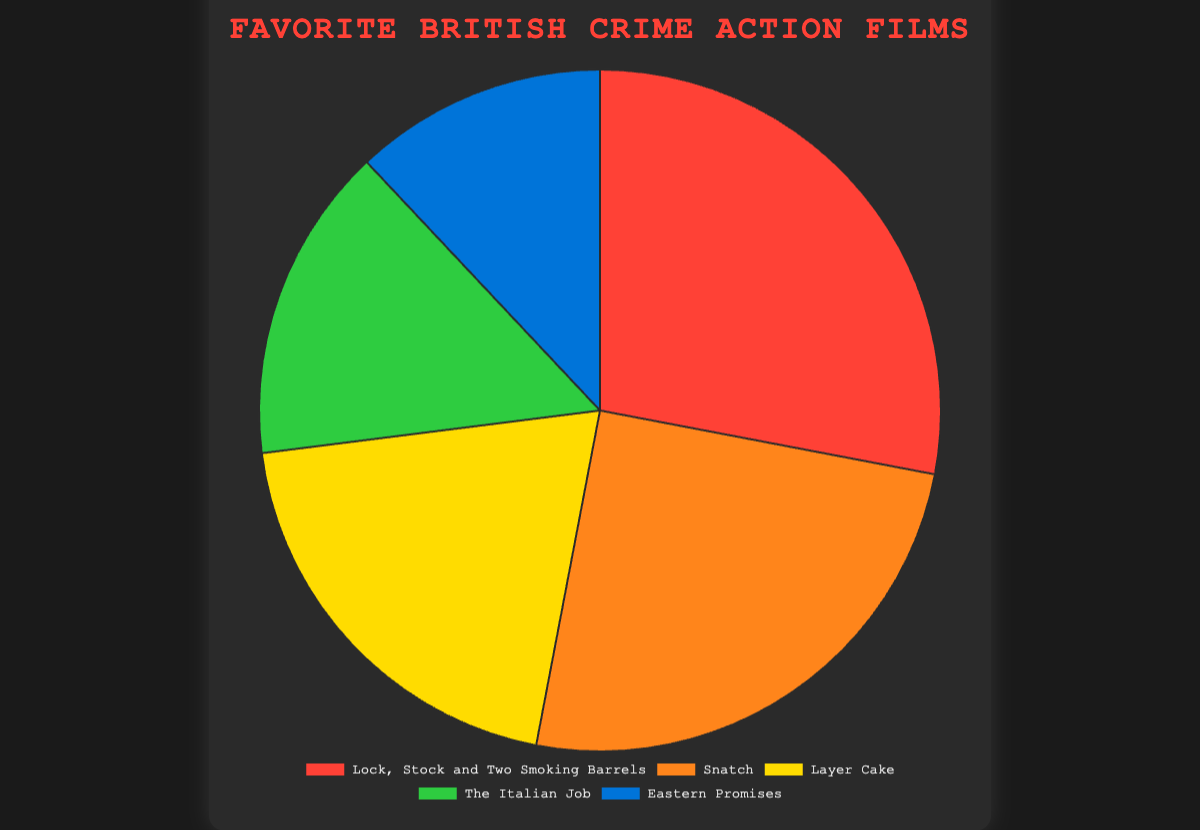Which film has the highest viewership percentage? The chart shows five films with their corresponding viewership percentages. The film "Lock, Stock and Two Smoking Barrels" has the highest percentage at 28%.
Answer: Lock, Stock and Two Smoking Barrels How much more percentage does "Lock, Stock and Two Smoking Barrels" have compared to "Eastern Promises"? "Lock, Stock and Two Smoking Barrels" has a viewership percentage of 28%, and "Eastern Promises" has 12%. The difference is 28% - 12% = 16%.
Answer: 16% What is the total viewership percentage of "Snatch" and "Layer Cake"? "Snatch" has a percentage of 25%, and "Layer Cake" has 20%. Adding these values, we get 25% + 20% = 45%.
Answer: 45% Which film has the lowest viewership percentage? Looking at the chart, "Eastern Promises" has the lowest viewership percentage at 12%.
Answer: Eastern Promises What is the average viewership percentage of all films? Sum the percentages of all films: 28% + 25% + 20% + 15% + 12% = 100%. There are 5 films. The average is 100% / 5 = 20%.
Answer: 20% Is there any film with a viewership percentage exactly equal to the average viewership percentage? The average viewership percentage is 20%. "Layer Cake" has exactly 20%.
Answer: Yes What percentage of films have a viewership percentage greater than 20%? Two films, "Lock, Stock and Two Smoking Barrels" (28%) and "Snatch" (25%), have percentages greater than 20%. There are 5 films in total, so 2/5 = 40%.
Answer: 40% What is the color representation of "The Italian Job"? From the visual attributes of the pie chart, "The Italian Job" is represented by the green segment.
Answer: Green How much greater is the viewership percentage of "Snatch" compared to "The Italian Job"? Subtract the percentage of "The Italian Job" (15%) from "Snatch" (25%): 25% - 15% = 10%.
Answer: 10% 